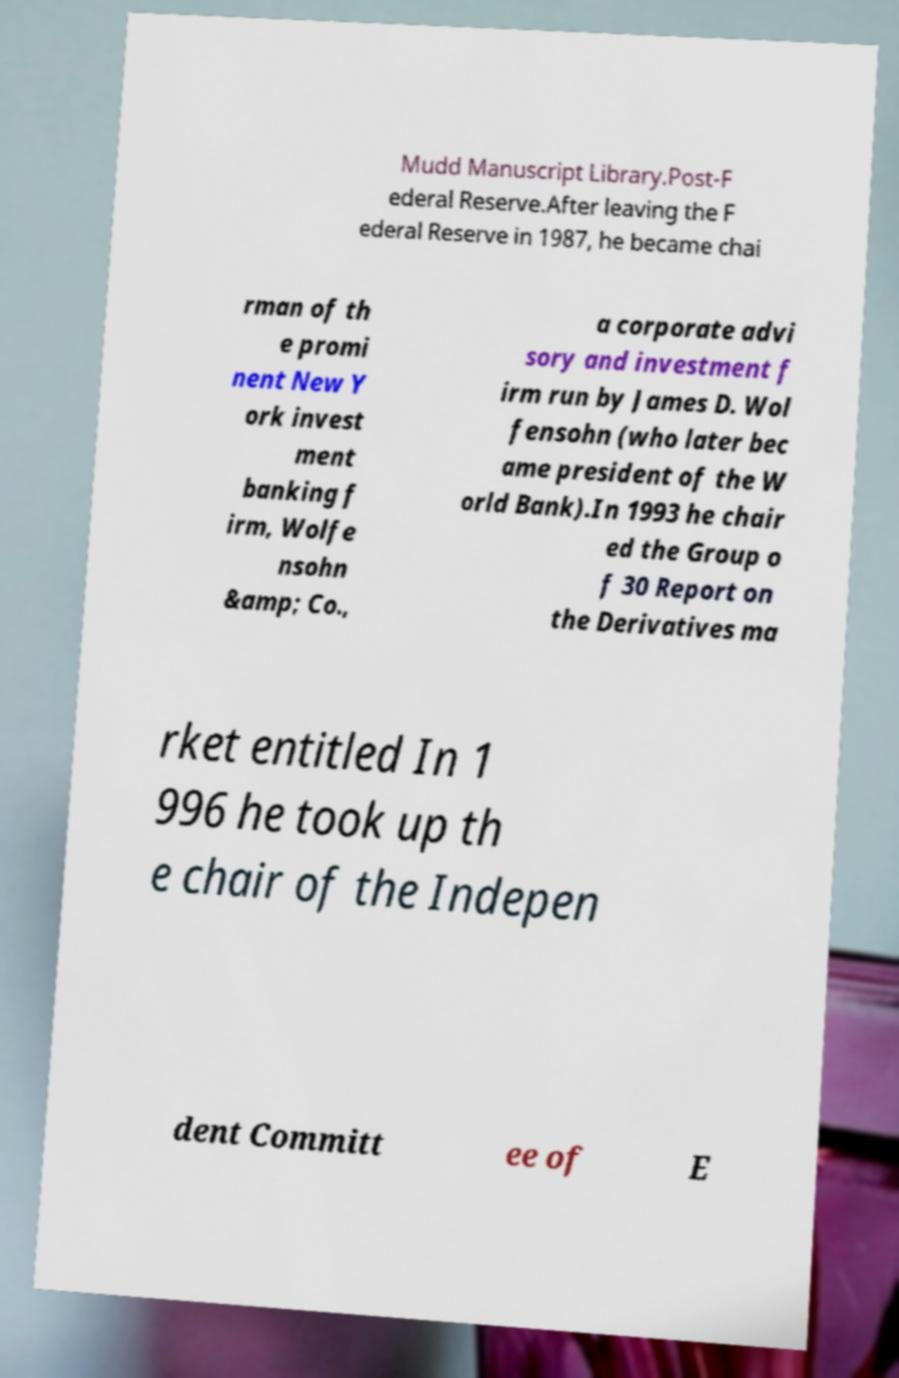Can you read and provide the text displayed in the image?This photo seems to have some interesting text. Can you extract and type it out for me? Mudd Manuscript Library.Post-F ederal Reserve.After leaving the F ederal Reserve in 1987, he became chai rman of th e promi nent New Y ork invest ment banking f irm, Wolfe nsohn &amp; Co., a corporate advi sory and investment f irm run by James D. Wol fensohn (who later bec ame president of the W orld Bank).In 1993 he chair ed the Group o f 30 Report on the Derivatives ma rket entitled In 1 996 he took up th e chair of the Indepen dent Committ ee of E 